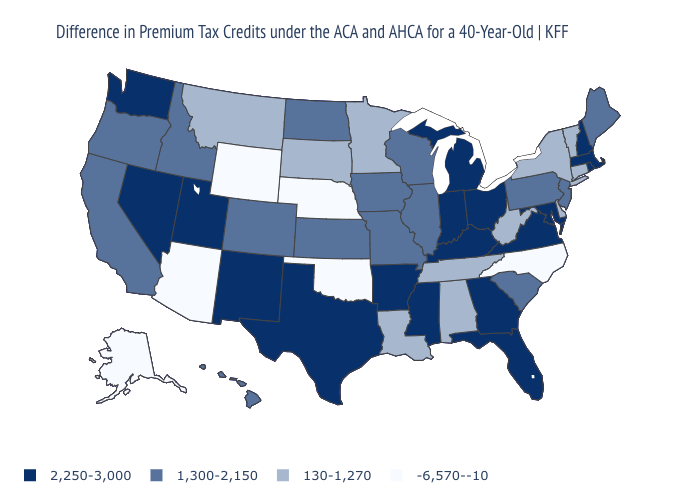Name the states that have a value in the range 1,300-2,150?
Short answer required. California, Colorado, Hawaii, Idaho, Illinois, Iowa, Kansas, Maine, Missouri, New Jersey, North Dakota, Oregon, Pennsylvania, South Carolina, Wisconsin. What is the value of Arizona?
Be succinct. -6,570--10. Does Massachusetts have a higher value than Maryland?
Quick response, please. No. What is the value of New York?
Quick response, please. 130-1,270. What is the value of New Hampshire?
Be succinct. 2,250-3,000. What is the value of Washington?
Concise answer only. 2,250-3,000. What is the value of Tennessee?
Give a very brief answer. 130-1,270. Does Colorado have the same value as South Carolina?
Concise answer only. Yes. Name the states that have a value in the range 2,250-3,000?
Answer briefly. Arkansas, Florida, Georgia, Indiana, Kentucky, Maryland, Massachusetts, Michigan, Mississippi, Nevada, New Hampshire, New Mexico, Ohio, Rhode Island, Texas, Utah, Virginia, Washington. What is the value of South Dakota?
Short answer required. 130-1,270. What is the highest value in states that border Michigan?
Quick response, please. 2,250-3,000. What is the value of Michigan?
Answer briefly. 2,250-3,000. What is the value of Kentucky?
Answer briefly. 2,250-3,000. Name the states that have a value in the range 1,300-2,150?
Concise answer only. California, Colorado, Hawaii, Idaho, Illinois, Iowa, Kansas, Maine, Missouri, New Jersey, North Dakota, Oregon, Pennsylvania, South Carolina, Wisconsin. 